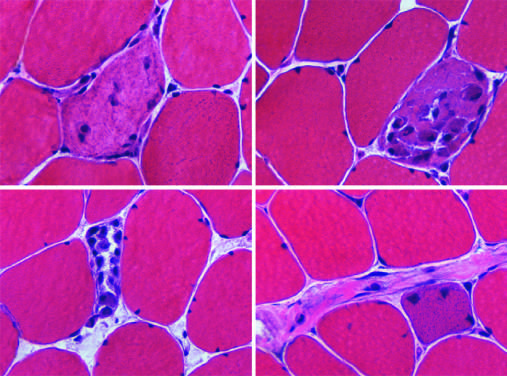re necrotic cells infiltrated by variable numbers of inflammatory cells?
Answer the question using a single word or phrase. Yes 